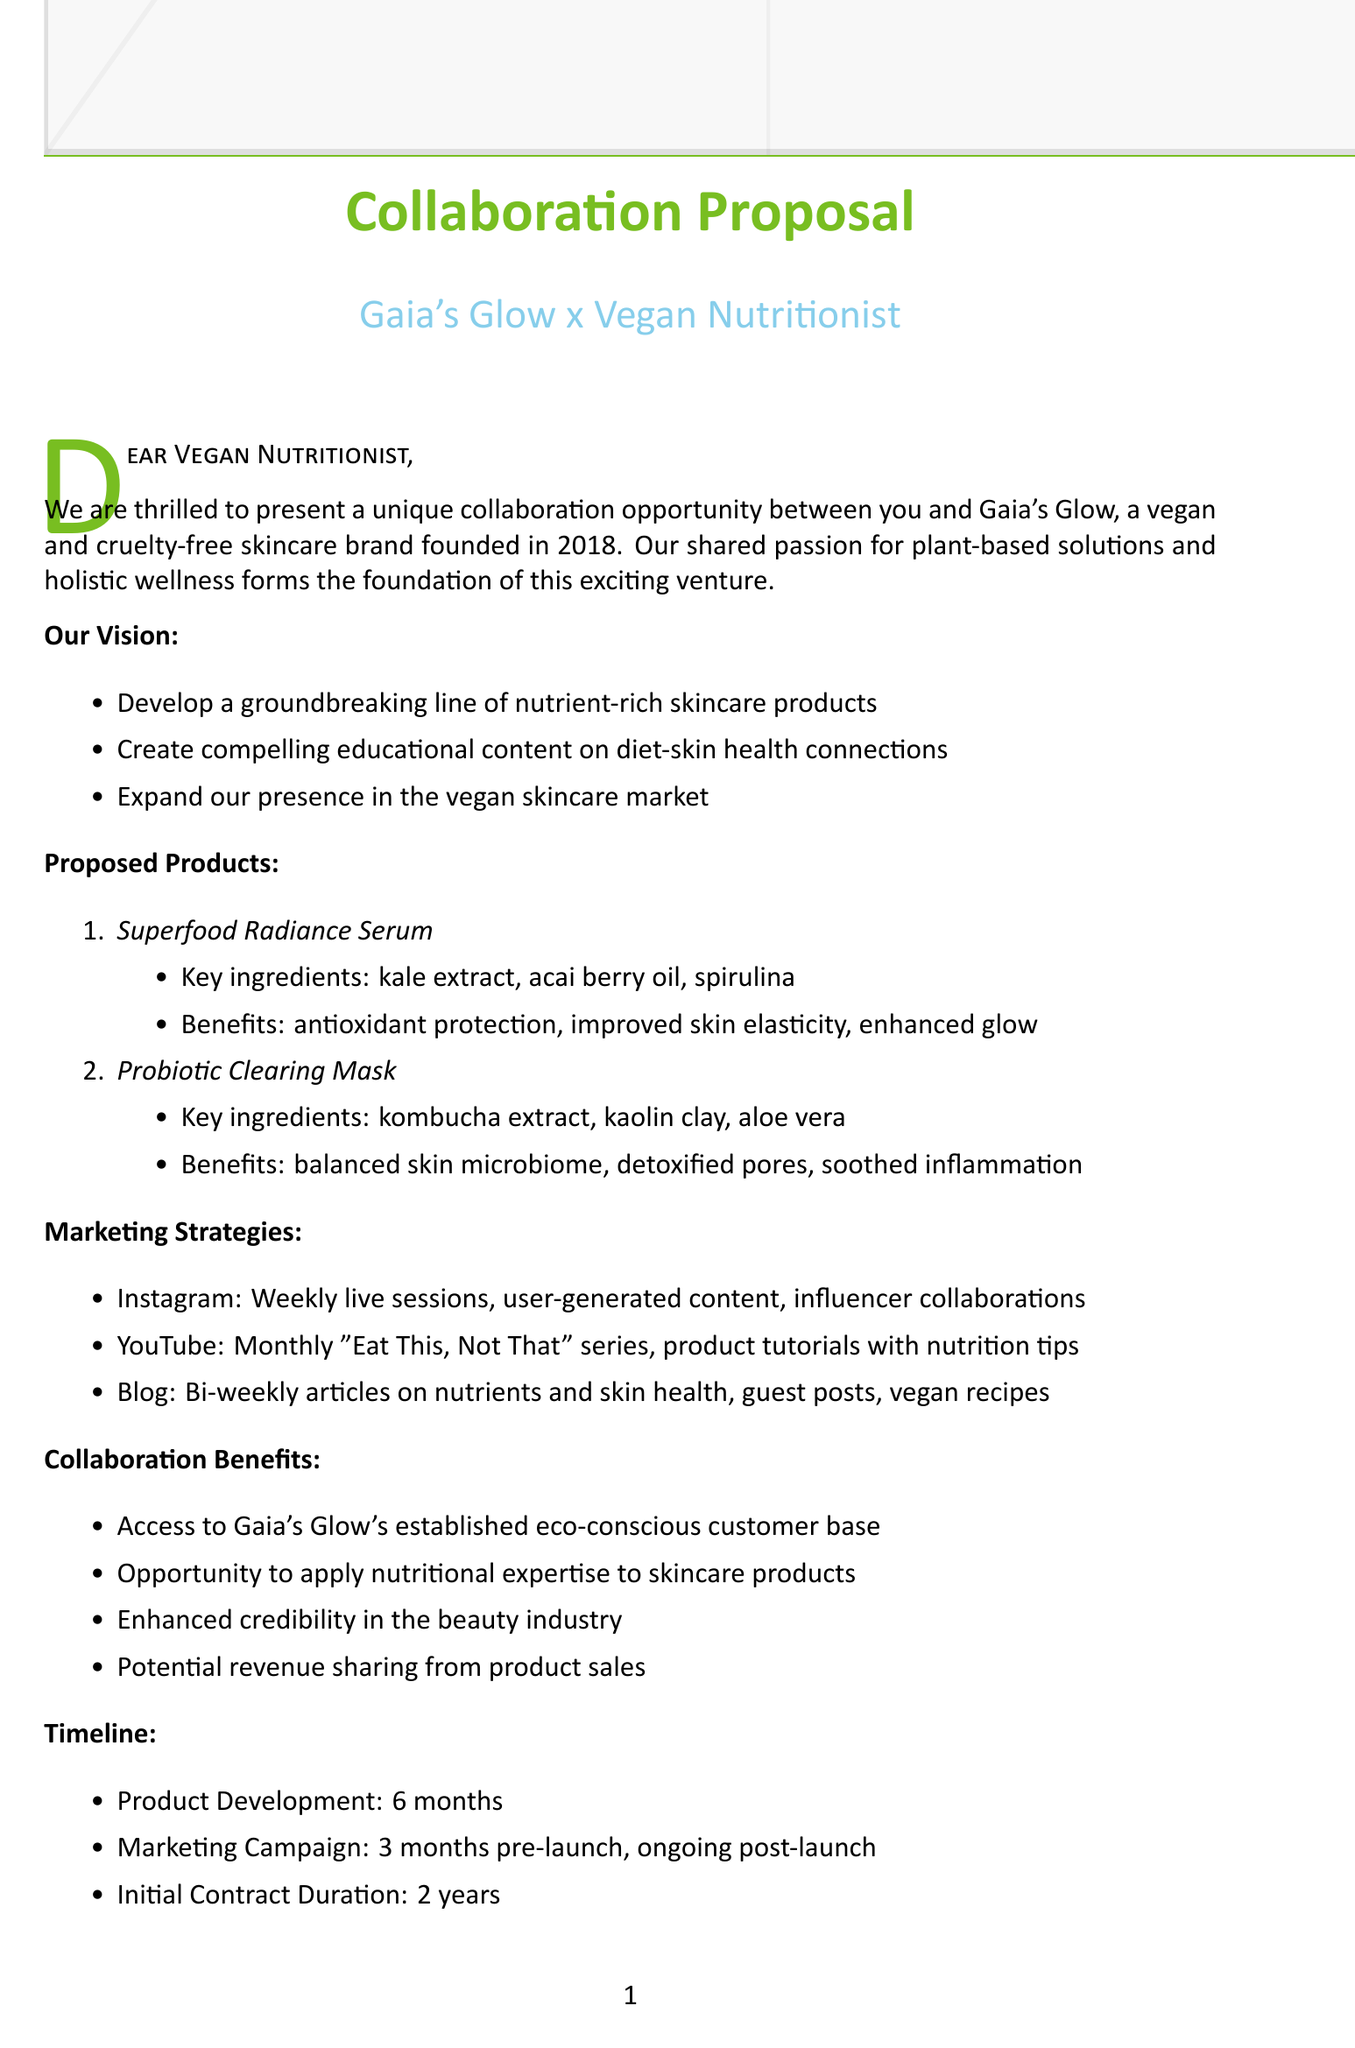What is the name of the brand? The brand referenced in the document is Gaia's Glow.
Answer: Gaia's Glow What year was Gaia's Glow founded? The document states that Gaia's Glow was founded in 2018.
Answer: 2018 What is one proposed product mentioned in the document? The document lists several proposed products, one of which is the Superfood Radiance Serum.
Answer: Superfood Radiance Serum How long will the product development take? The timeline in the document indicates that product development will take 6 months.
Answer: 6 months What is one benefit of the Probiotic Clearing Mask? The document outlines benefits of this mask, including balancing the skin microbiome.
Answer: Balances skin microbiome What is the duration of the initial contract proposed for the collaboration? The document specifies that the initial contract duration is 2 years.
Answer: 2 years What is one marketing strategy mentioned for Instagram? The document lists several activities, one being weekly live sessions on diet and skincare.
Answer: Weekly live sessions How does this collaboration target consumer trends? The document cites growing interest in "inside-out" beauty approaches as a consumer trend.
Answer: Inside-out beauty What type of agreement protects proprietary formulations? The document states that a non-disclosure agreement is required for this purpose.
Answer: Non-disclosure agreement 